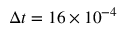Convert formula to latex. <formula><loc_0><loc_0><loc_500><loc_500>\Delta t = 1 6 \times 1 0 ^ { - 4 }</formula> 